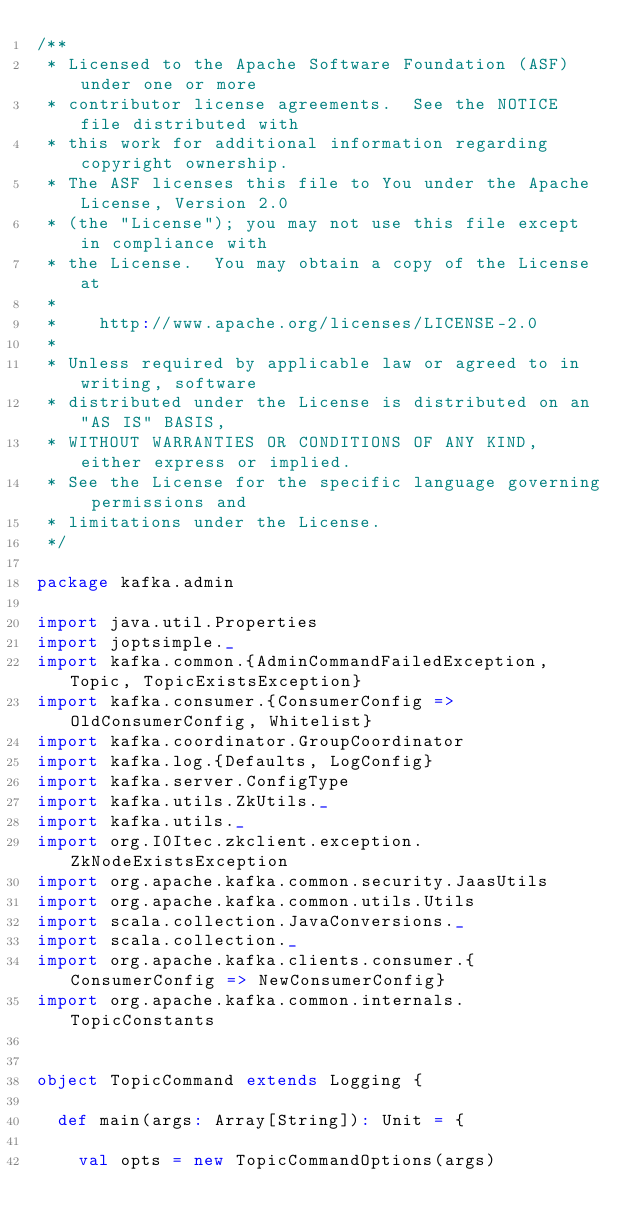Convert code to text. <code><loc_0><loc_0><loc_500><loc_500><_Scala_>/**
 * Licensed to the Apache Software Foundation (ASF) under one or more
 * contributor license agreements.  See the NOTICE file distributed with
 * this work for additional information regarding copyright ownership.
 * The ASF licenses this file to You under the Apache License, Version 2.0
 * (the "License"); you may not use this file except in compliance with
 * the License.  You may obtain a copy of the License at
 *
 *    http://www.apache.org/licenses/LICENSE-2.0
 *
 * Unless required by applicable law or agreed to in writing, software
 * distributed under the License is distributed on an "AS IS" BASIS,
 * WITHOUT WARRANTIES OR CONDITIONS OF ANY KIND, either express or implied.
 * See the License for the specific language governing permissions and
 * limitations under the License.
 */

package kafka.admin

import java.util.Properties
import joptsimple._
import kafka.common.{AdminCommandFailedException, Topic, TopicExistsException}
import kafka.consumer.{ConsumerConfig => OldConsumerConfig, Whitelist}
import kafka.coordinator.GroupCoordinator
import kafka.log.{Defaults, LogConfig}
import kafka.server.ConfigType
import kafka.utils.ZkUtils._
import kafka.utils._
import org.I0Itec.zkclient.exception.ZkNodeExistsException
import org.apache.kafka.common.security.JaasUtils
import org.apache.kafka.common.utils.Utils
import scala.collection.JavaConversions._
import scala.collection._
import org.apache.kafka.clients.consumer.{ConsumerConfig => NewConsumerConfig}
import org.apache.kafka.common.internals.TopicConstants


object TopicCommand extends Logging {

  def main(args: Array[String]): Unit = {

    val opts = new TopicCommandOptions(args)
</code> 